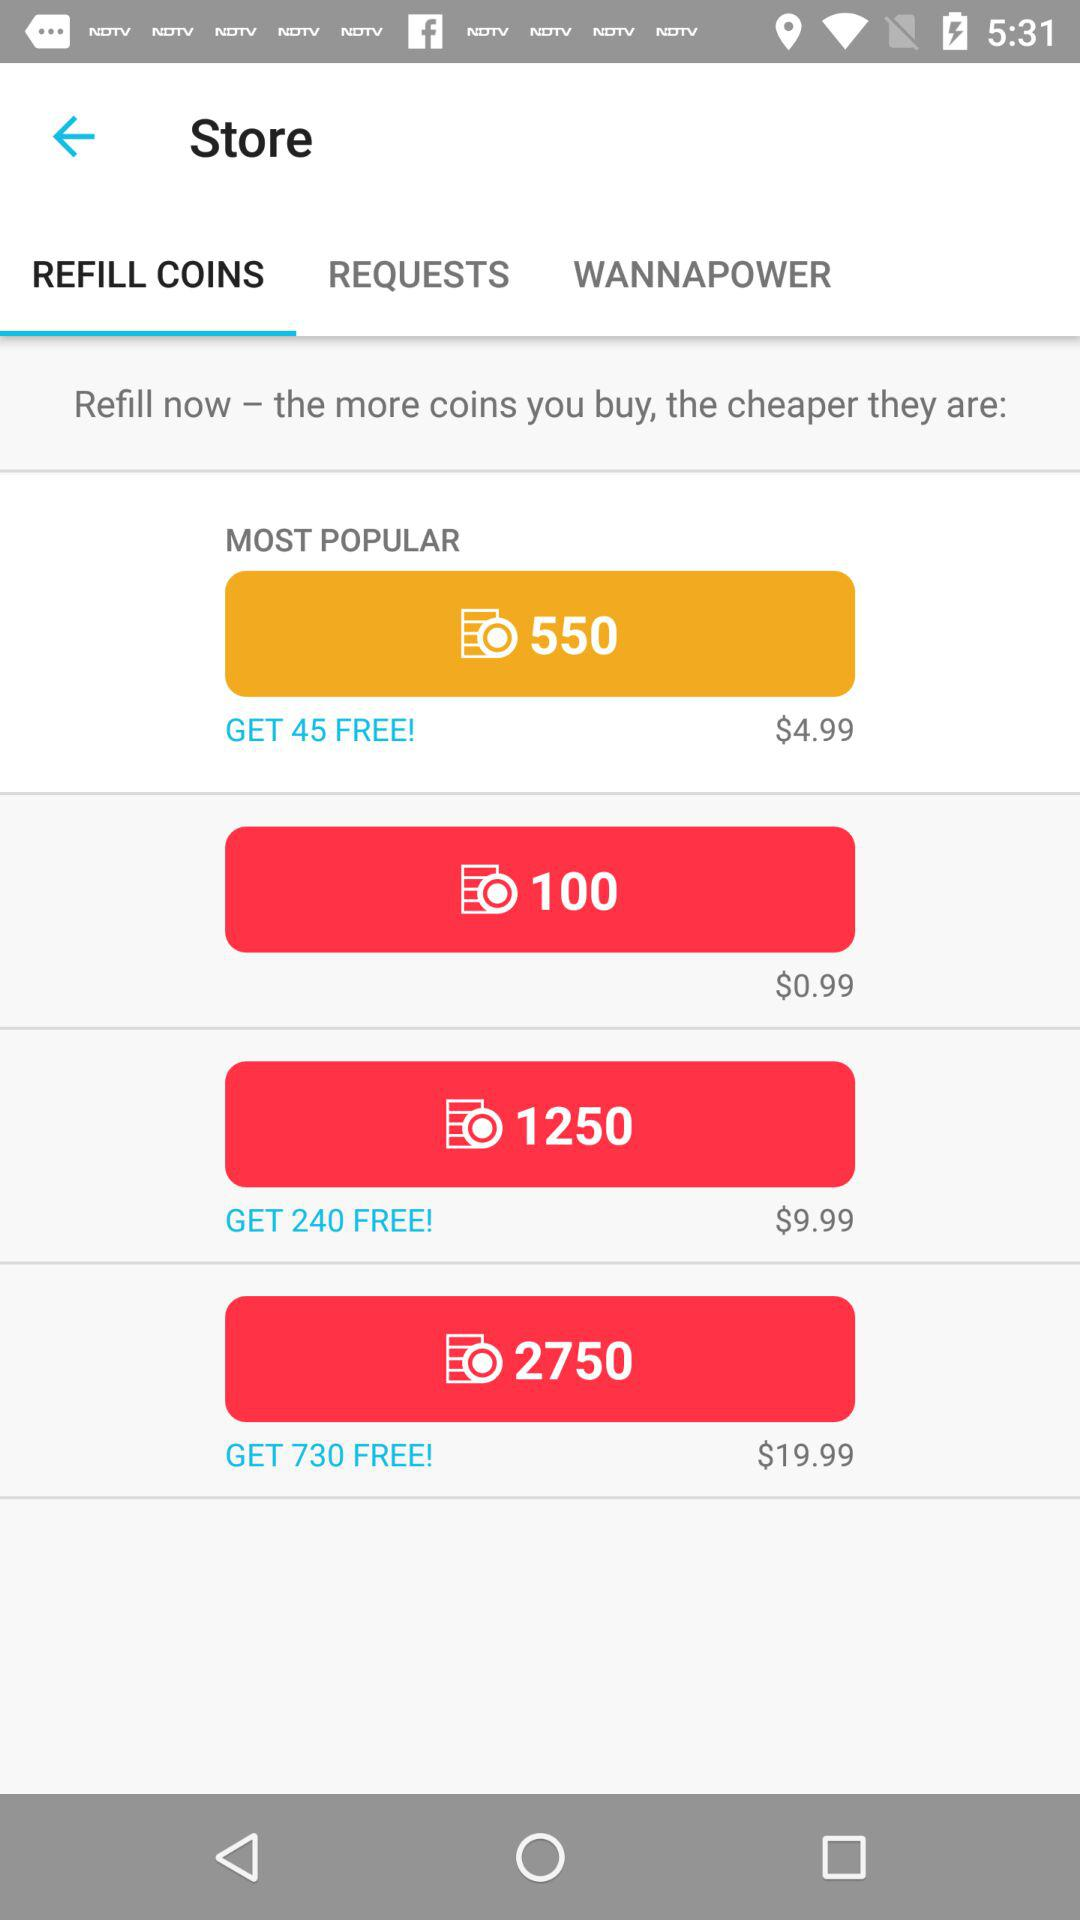What is the price of refilling 100 coins? The price of refilling 100 coins is $0.99. 